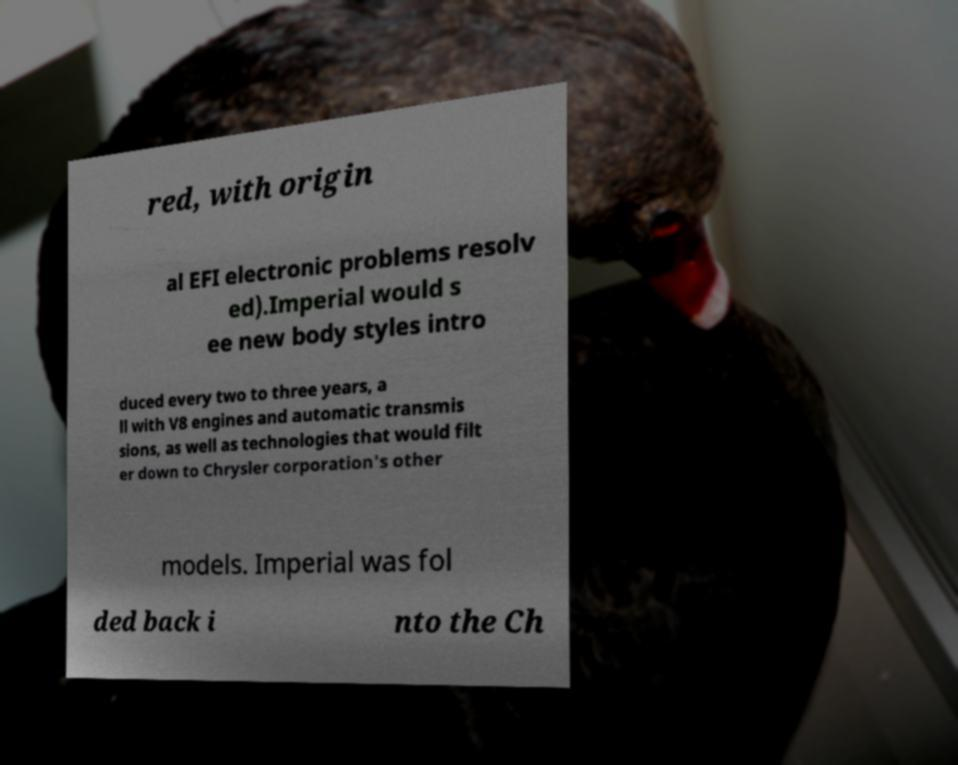There's text embedded in this image that I need extracted. Can you transcribe it verbatim? red, with origin al EFI electronic problems resolv ed).Imperial would s ee new body styles intro duced every two to three years, a ll with V8 engines and automatic transmis sions, as well as technologies that would filt er down to Chrysler corporation's other models. Imperial was fol ded back i nto the Ch 